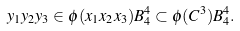<formula> <loc_0><loc_0><loc_500><loc_500>y _ { 1 } y _ { 2 } y _ { 3 } \in \phi ( x _ { 1 } x _ { 2 } x _ { 3 } ) B _ { 4 } ^ { 4 } \subset \phi ( C ^ { 3 } ) B _ { 4 } ^ { 4 } .</formula> 